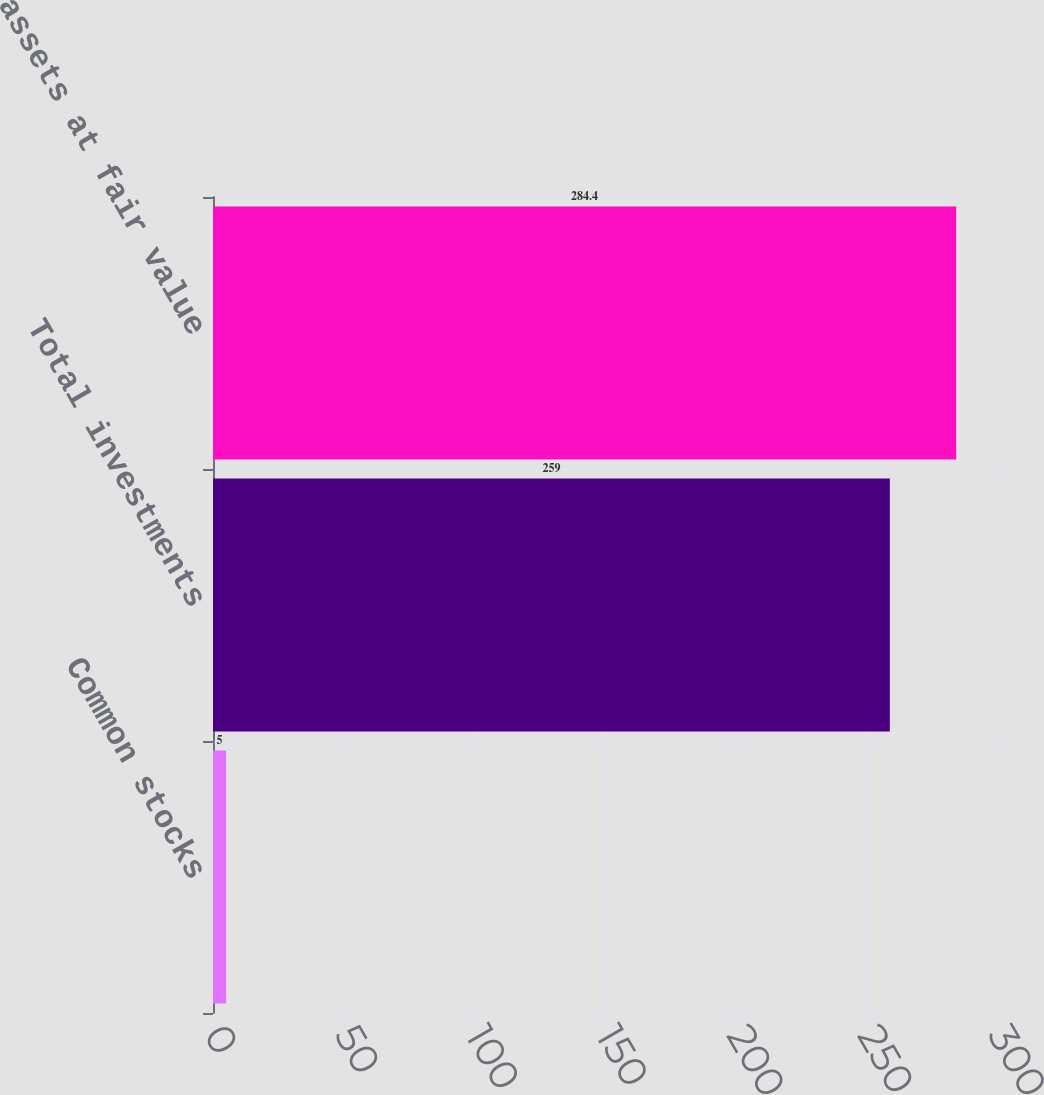Convert chart. <chart><loc_0><loc_0><loc_500><loc_500><bar_chart><fcel>Common stocks<fcel>Total investments<fcel>Total assets at fair value<nl><fcel>5<fcel>259<fcel>284.4<nl></chart> 